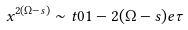Convert formula to latex. <formula><loc_0><loc_0><loc_500><loc_500>x ^ { 2 ( \Omega - s ) } \sim t 0 1 - 2 ( \Omega - s ) e \tau</formula> 